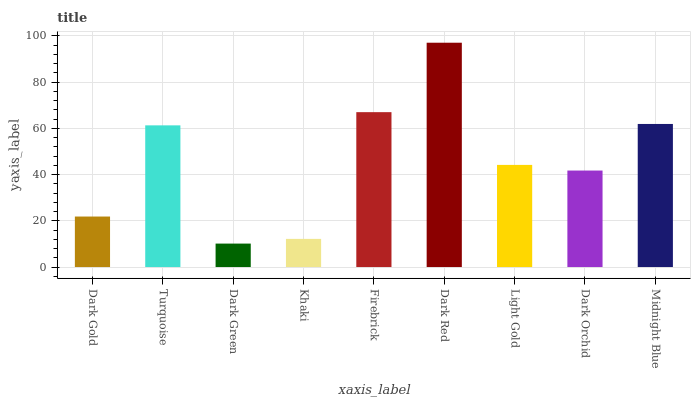Is Turquoise the minimum?
Answer yes or no. No. Is Turquoise the maximum?
Answer yes or no. No. Is Turquoise greater than Dark Gold?
Answer yes or no. Yes. Is Dark Gold less than Turquoise?
Answer yes or no. Yes. Is Dark Gold greater than Turquoise?
Answer yes or no. No. Is Turquoise less than Dark Gold?
Answer yes or no. No. Is Light Gold the high median?
Answer yes or no. Yes. Is Light Gold the low median?
Answer yes or no. Yes. Is Firebrick the high median?
Answer yes or no. No. Is Midnight Blue the low median?
Answer yes or no. No. 